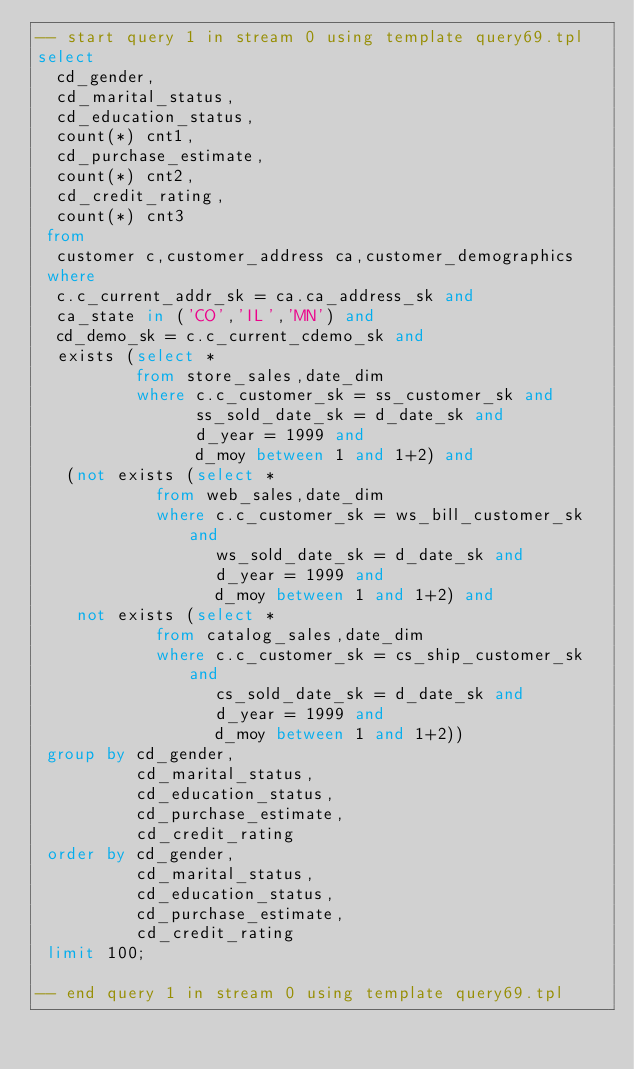<code> <loc_0><loc_0><loc_500><loc_500><_SQL_>-- start query 1 in stream 0 using template query69.tpl
select 
  cd_gender,
  cd_marital_status,
  cd_education_status,
  count(*) cnt1,
  cd_purchase_estimate,
  count(*) cnt2,
  cd_credit_rating,
  count(*) cnt3
 from
  customer c,customer_address ca,customer_demographics
 where
  c.c_current_addr_sk = ca.ca_address_sk and
  ca_state in ('CO','IL','MN') and
  cd_demo_sk = c.c_current_cdemo_sk and
  exists (select *
          from store_sales,date_dim
          where c.c_customer_sk = ss_customer_sk and
                ss_sold_date_sk = d_date_sk and
                d_year = 1999 and
                d_moy between 1 and 1+2) and
   (not exists (select *
            from web_sales,date_dim
            where c.c_customer_sk = ws_bill_customer_sk and
                  ws_sold_date_sk = d_date_sk and
                  d_year = 1999 and
                  d_moy between 1 and 1+2) and
    not exists (select *
            from catalog_sales,date_dim
            where c.c_customer_sk = cs_ship_customer_sk and
                  cs_sold_date_sk = d_date_sk and
                  d_year = 1999 and
                  d_moy between 1 and 1+2))
 group by cd_gender,
          cd_marital_status,
          cd_education_status,
          cd_purchase_estimate,
          cd_credit_rating
 order by cd_gender,
          cd_marital_status,
          cd_education_status,
          cd_purchase_estimate,
          cd_credit_rating
 limit 100;

-- end query 1 in stream 0 using template query69.tpl
</code> 